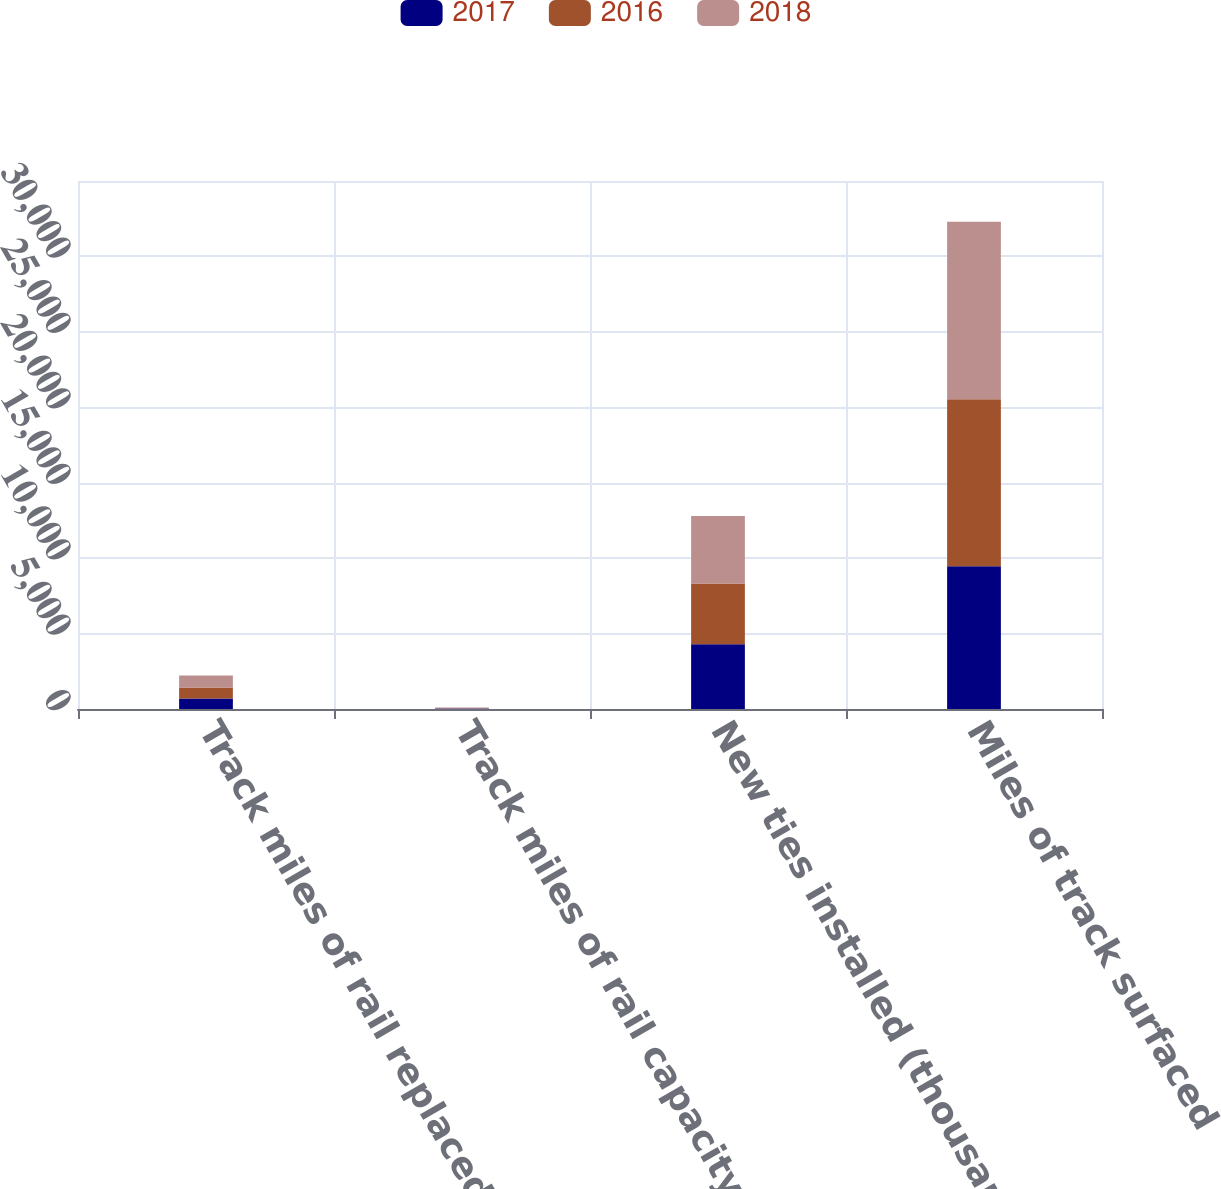Convert chart. <chart><loc_0><loc_0><loc_500><loc_500><stacked_bar_chart><ecel><fcel>Track miles of rail replaced<fcel>Track miles of rail capacity<fcel>New ties installed (thousands)<fcel>Miles of track surfaced<nl><fcel>2017<fcel>700<fcel>39<fcel>4285<fcel>9466<nl><fcel>2016<fcel>731<fcel>11<fcel>4026<fcel>11071<nl><fcel>2018<fcel>791<fcel>52<fcel>4482<fcel>11764<nl></chart> 